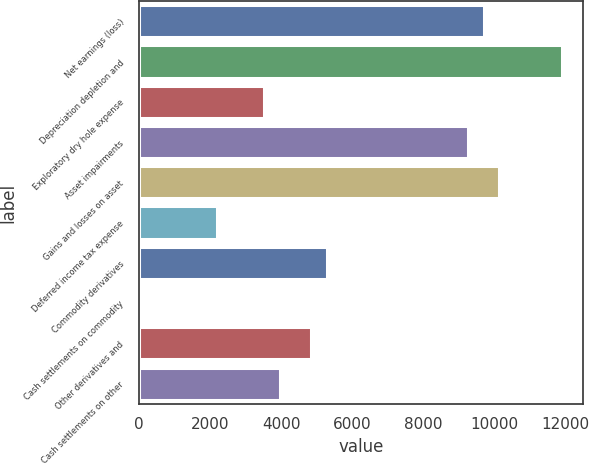<chart> <loc_0><loc_0><loc_500><loc_500><bar_chart><fcel>Net earnings (loss)<fcel>Depreciation depletion and<fcel>Exploratory dry hole expense<fcel>Asset impairments<fcel>Gains and losses on asset<fcel>Deferred income tax expense<fcel>Commodity derivatives<fcel>Cash settlements on commodity<fcel>Other derivatives and<fcel>Cash settlements on other<nl><fcel>9698.6<fcel>11902.6<fcel>3527.4<fcel>9257.8<fcel>10139.4<fcel>2205<fcel>5290.6<fcel>1<fcel>4849.8<fcel>3968.2<nl></chart> 